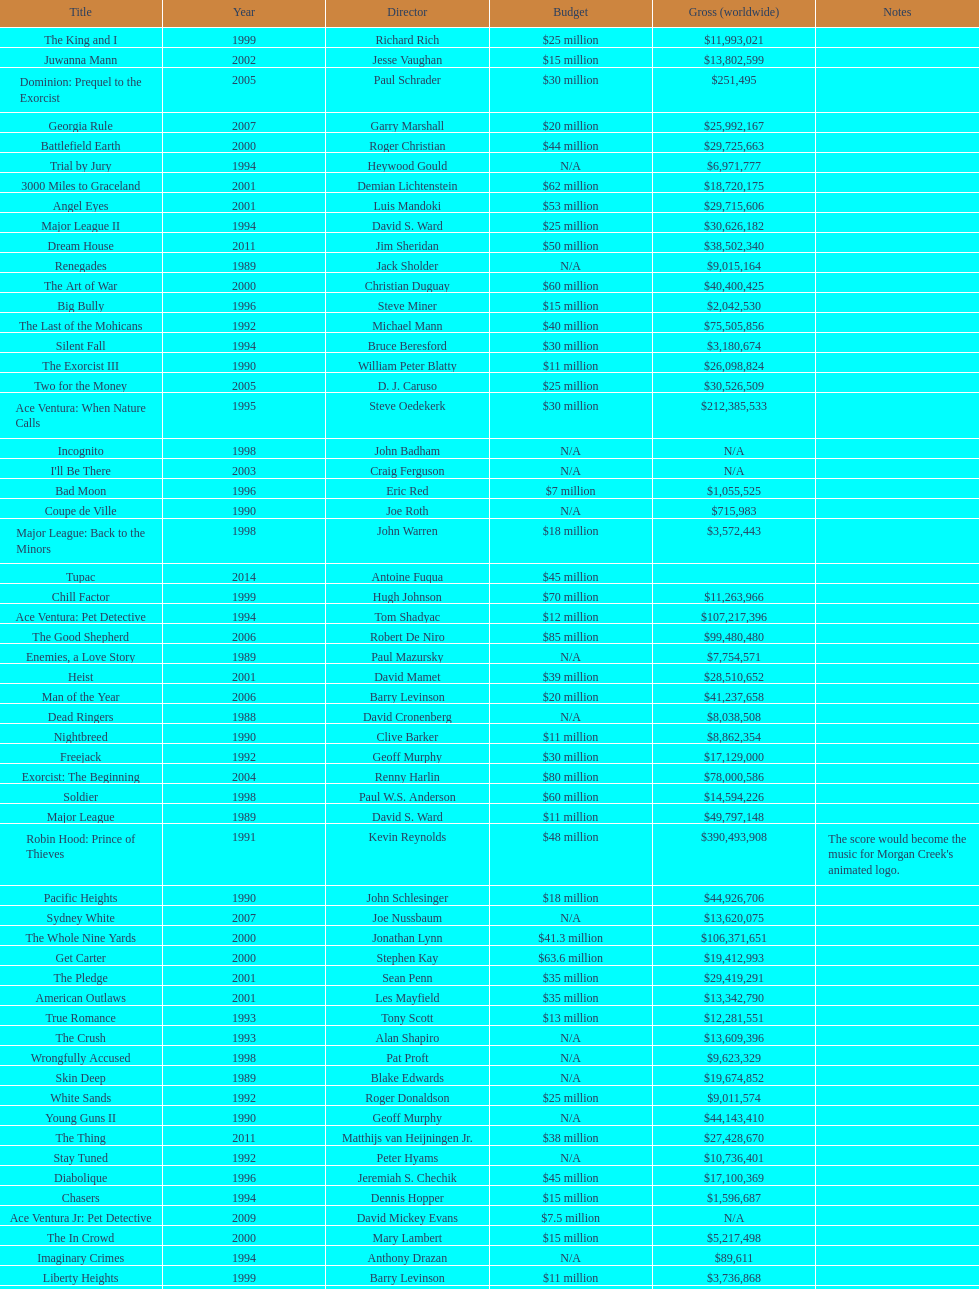What was the last movie morgan creek made for a budget under thirty million? Ace Ventura Jr: Pet Detective. 